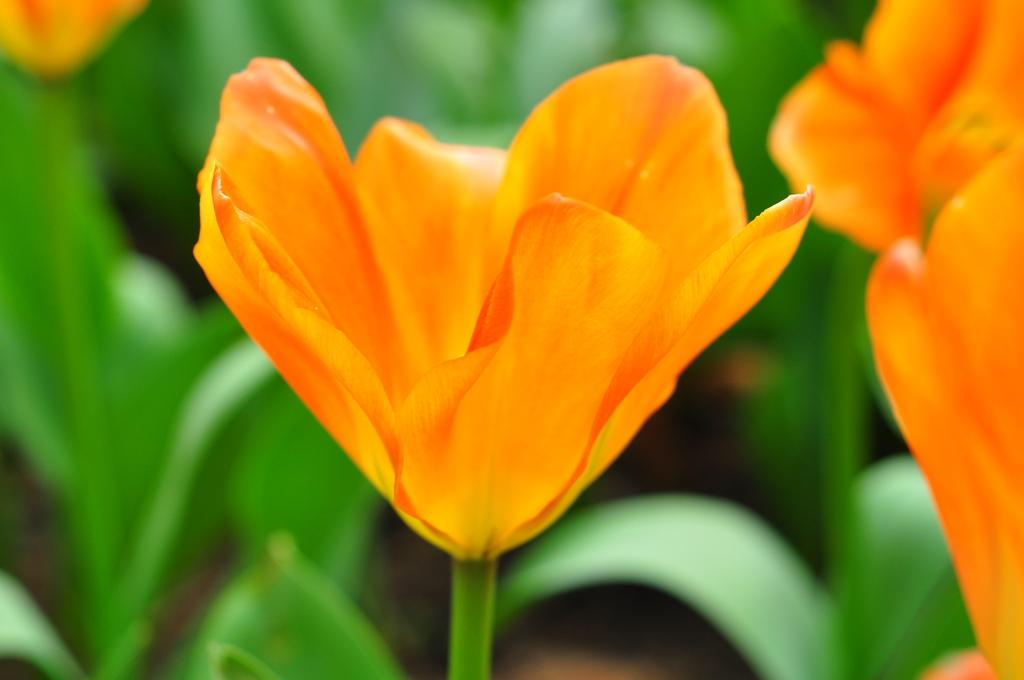What type of plants can be seen in the image? There are flowers in the image. What color are the flowers? The flowers are orange in color. What other part of the plant is visible in the image? There are green leaves in the image. What type of brick is used to construct the representative building in the image? There is no brick or building present in the image; it only features flowers and green leaves. 